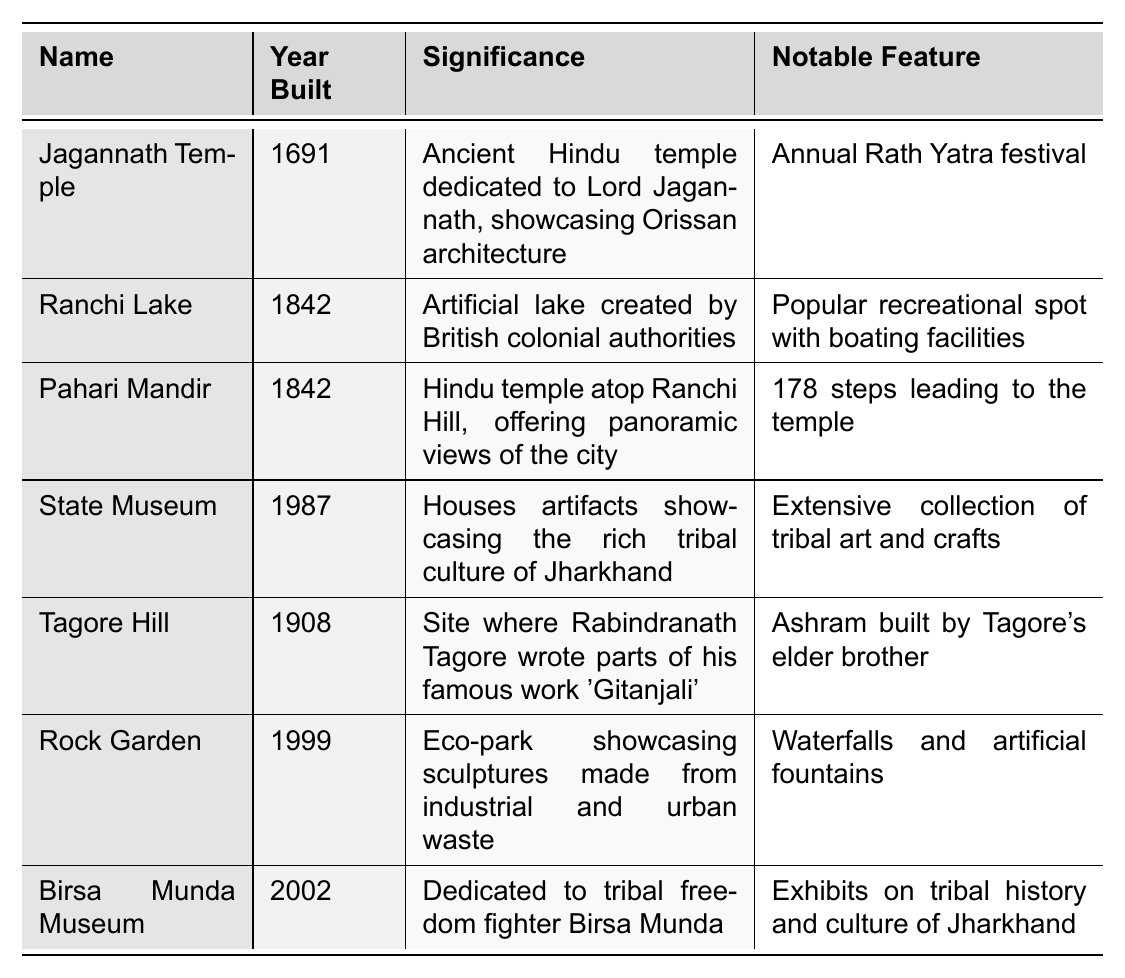What is the name of the temple dedicated to Lord Jagannath? The table lists "Jagannath Temple" as the name of the temple dedicated to Lord Jagannath.
Answer: Jagannath Temple In which year was Ranchi Lake built? According to the table, Ranchi Lake was built in the year 1842.
Answer: 1842 What significant feature is associated with the Pahari Mandir? The notable feature listed for Pahari Mandir is "178 steps leading to the temple."
Answer: 178 steps Does the State Museum showcase artifacts related to tribal culture? Yes, the table indicates that the State Museum houses artifacts showcasing the rich tribal culture of Jharkhand.
Answer: Yes Which landmark was established most recently? The table shows that the Birsa Munda Museum, built in 2002, is the most recently established landmark.
Answer: Birsa Munda Museum What was created by British colonial authorities in 1842? The table states that Ranchi Lake was created by British colonial authorities in the year 1842.
Answer: Ranchi Lake Which landmark offers panoramic views of the city of Ranchi? The Pahari Mandir, as indicated in the table, is located atop Ranchi Hill and offers panoramic views of the city.
Answer: Pahari Mandir How many landmarks were built in the 1800s according to the table? The table lists three landmarks built in the 1800s: Ranchi Lake (1842), Pahari Mandir (1842), and Tagore Hill (1908).
Answer: 3 Is there any landmark dedicated to a tribal freedom fighter? Yes, the table identifies the Birsa Munda Museum as dedicated to tribal freedom fighter Birsa Munda.
Answer: Yes Which landmark's notable feature includes an ashram built by Tagore's elder brother? According to the table, Tagore Hill includes an ashram built by Rabindranath Tagore's elder brother as its notable feature.
Answer: Tagore Hill 